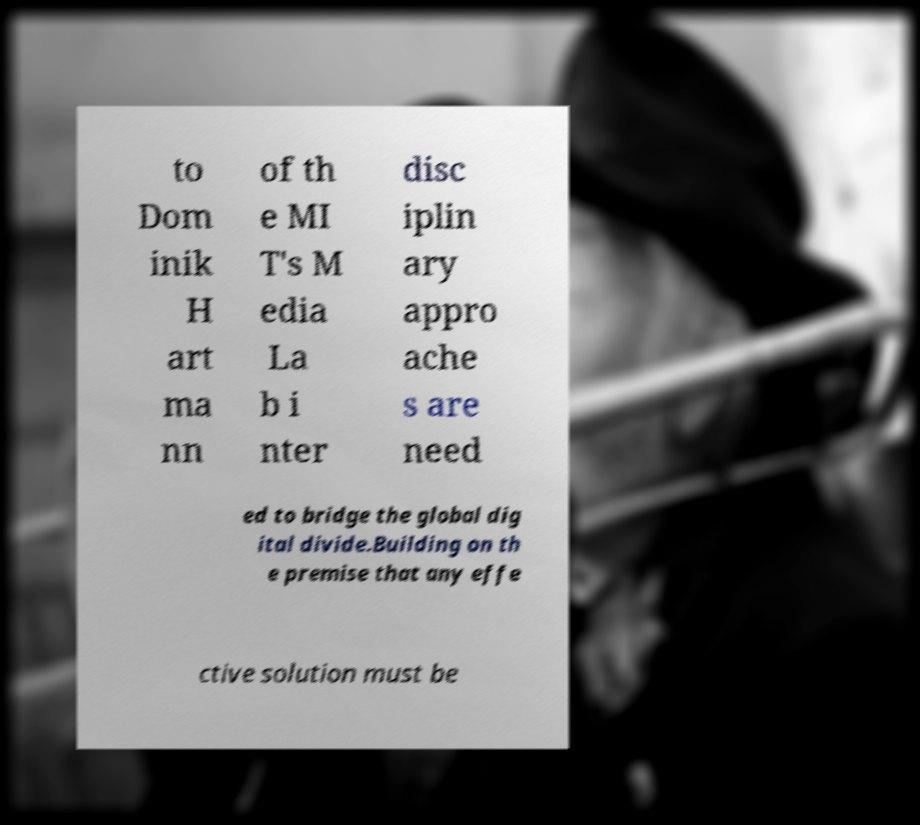Can you read and provide the text displayed in the image?This photo seems to have some interesting text. Can you extract and type it out for me? to Dom inik H art ma nn of th e MI T's M edia La b i nter disc iplin ary appro ache s are need ed to bridge the global dig ital divide.Building on th e premise that any effe ctive solution must be 